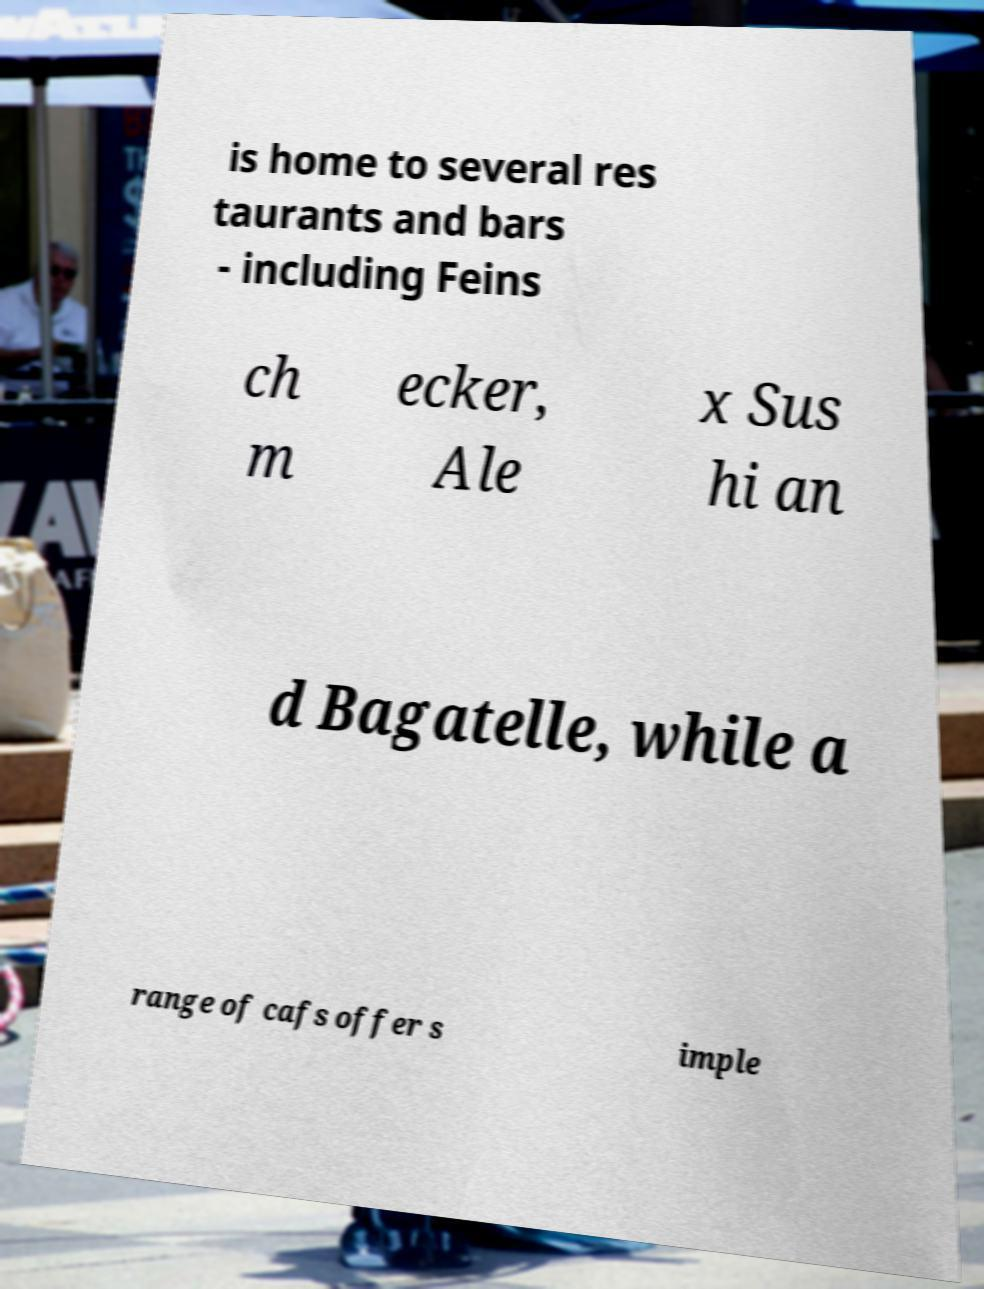Could you extract and type out the text from this image? is home to several res taurants and bars - including Feins ch m ecker, Ale x Sus hi an d Bagatelle, while a range of cafs offer s imple 